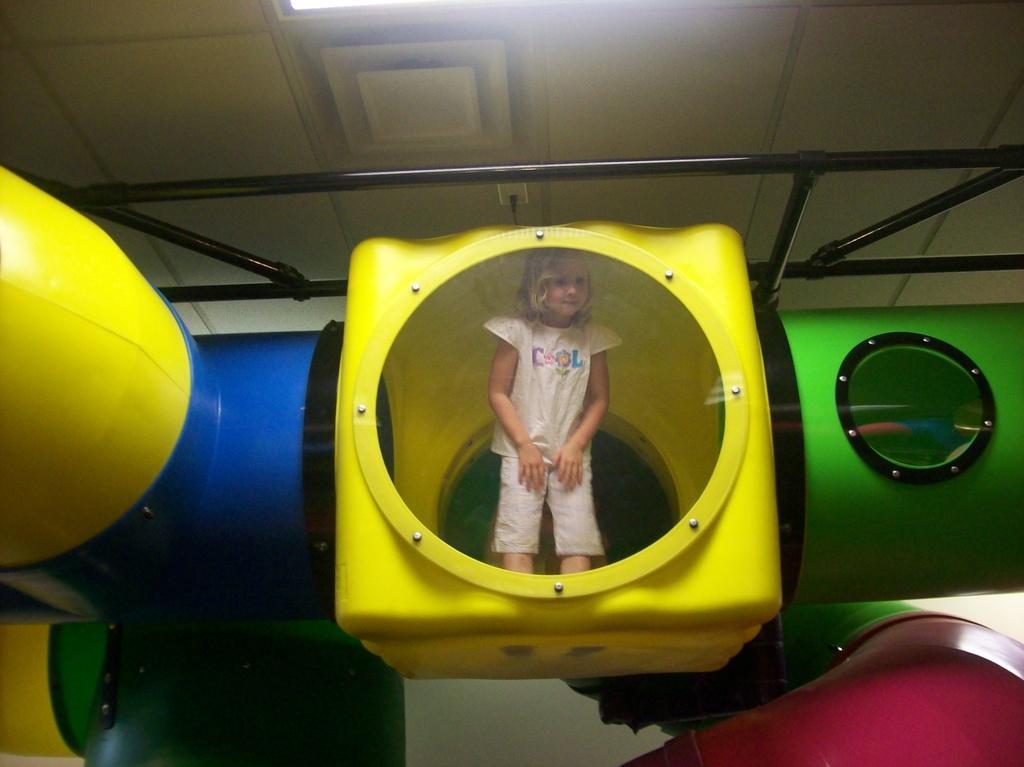Could you give a brief overview of what you see in this image? In this image we can see a girl is standing. Here we can see poles, rods, and objects. In the background we can see ceiling and a light. 